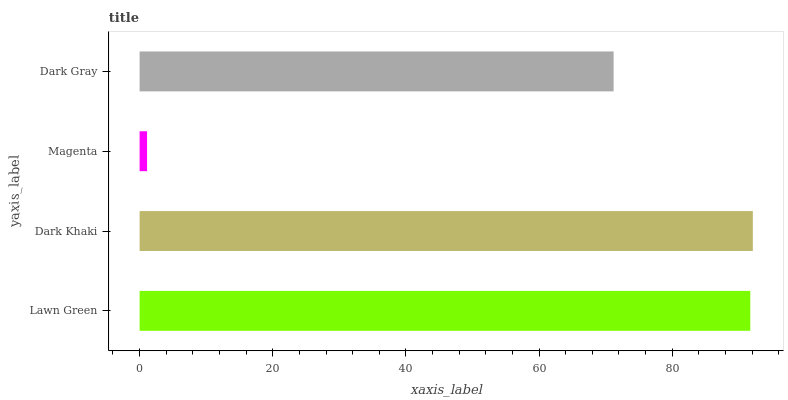Is Magenta the minimum?
Answer yes or no. Yes. Is Dark Khaki the maximum?
Answer yes or no. Yes. Is Dark Khaki the minimum?
Answer yes or no. No. Is Magenta the maximum?
Answer yes or no. No. Is Dark Khaki greater than Magenta?
Answer yes or no. Yes. Is Magenta less than Dark Khaki?
Answer yes or no. Yes. Is Magenta greater than Dark Khaki?
Answer yes or no. No. Is Dark Khaki less than Magenta?
Answer yes or no. No. Is Lawn Green the high median?
Answer yes or no. Yes. Is Dark Gray the low median?
Answer yes or no. Yes. Is Dark Gray the high median?
Answer yes or no. No. Is Lawn Green the low median?
Answer yes or no. No. 